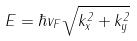<formula> <loc_0><loc_0><loc_500><loc_500>E = \hbar { v } _ { F } \sqrt { k _ { x } ^ { 2 } + k _ { y } ^ { 2 } }</formula> 